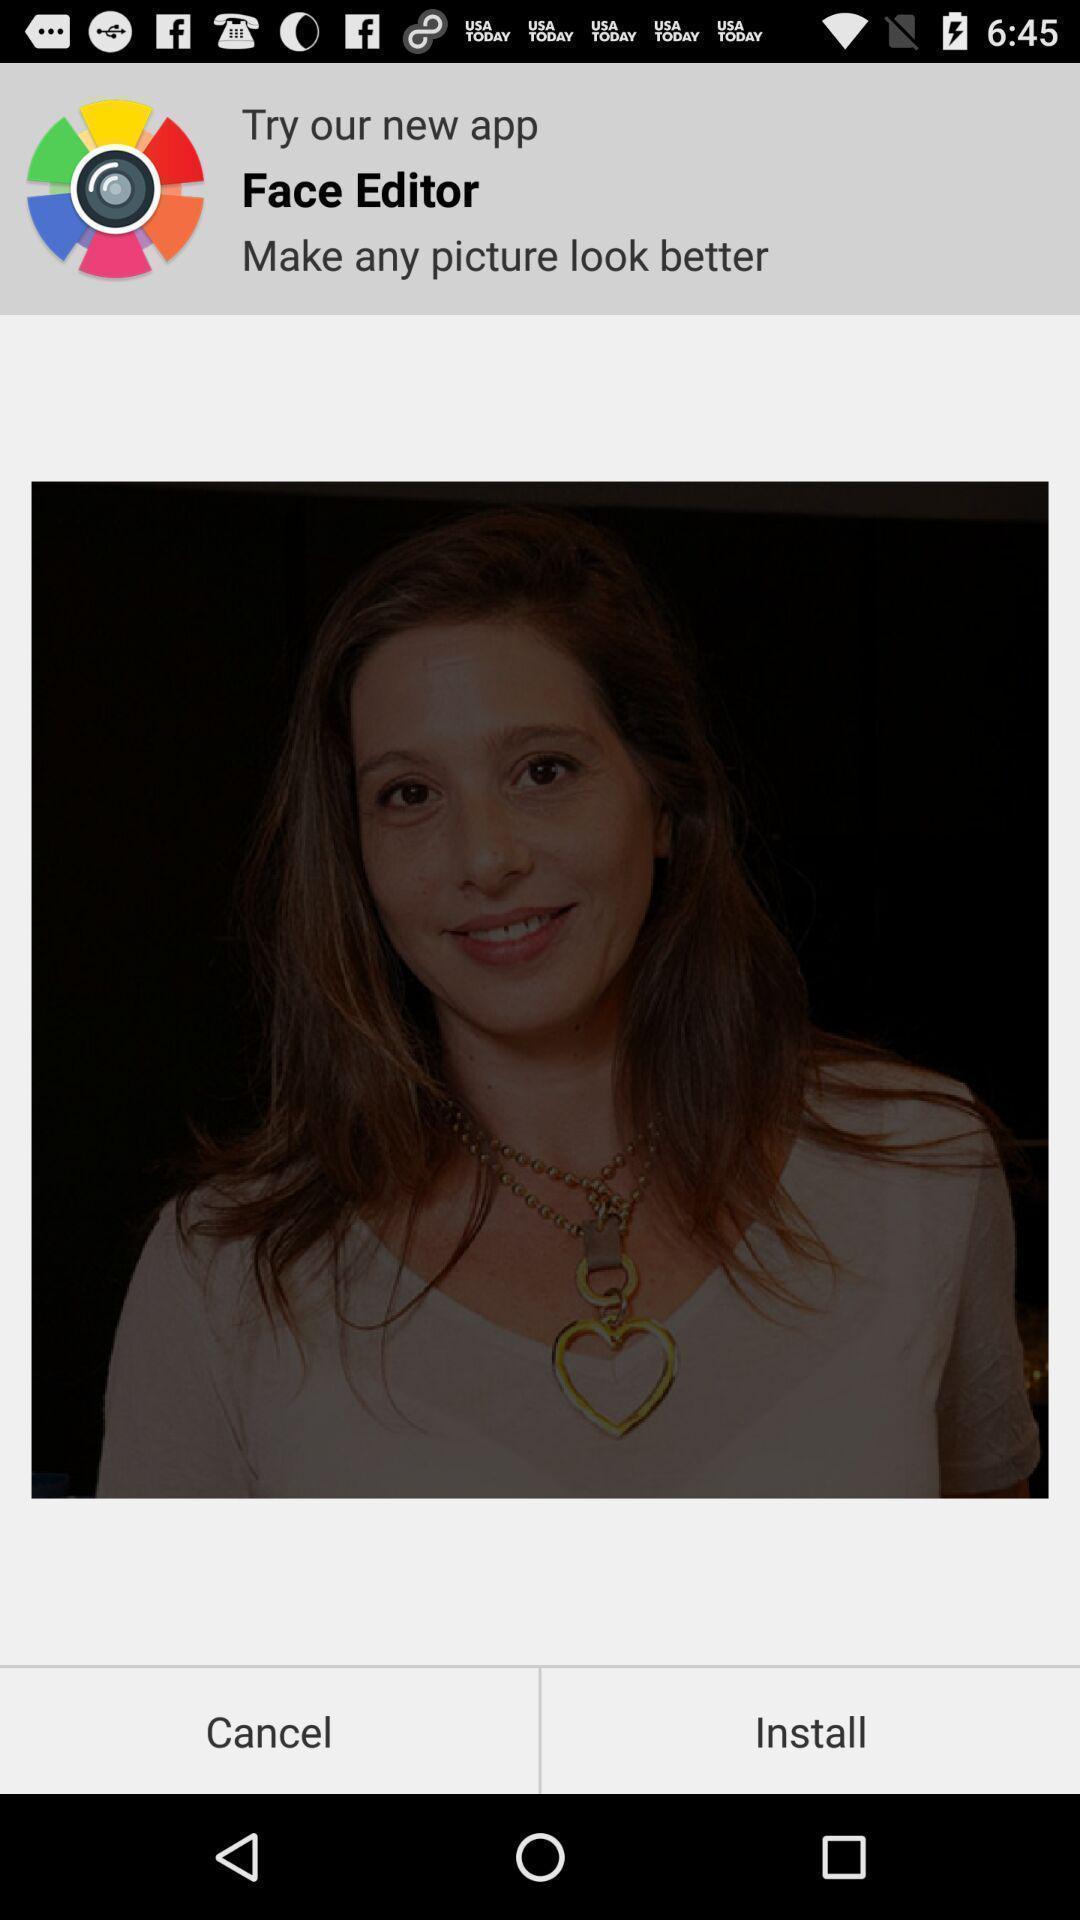Describe this image in words. Page showing an application with install option. 